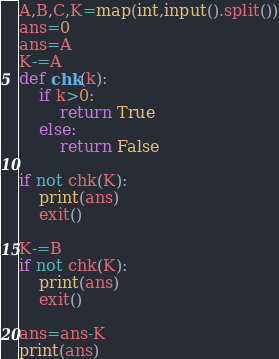<code> <loc_0><loc_0><loc_500><loc_500><_Python_>A,B,C,K=map(int,input().split())
ans=0
ans=A
K-=A
def chk(k):
    if k>0:
        return True
    else:
        return False

if not chk(K):
    print(ans)
    exit()

K-=B
if not chk(K):
    print(ans)
    exit()

ans=ans-K
print(ans)</code> 